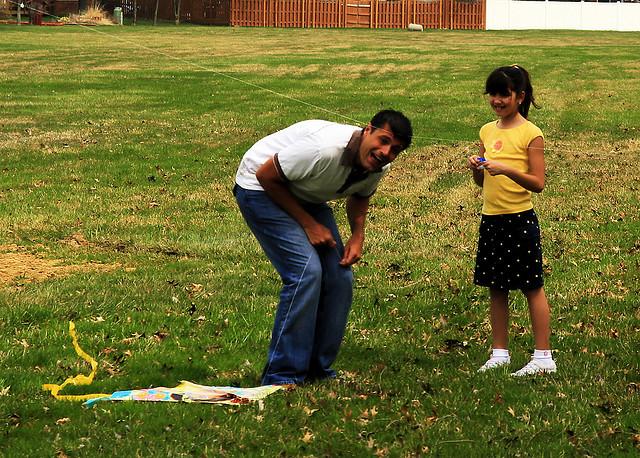What are they trying to fly?
Answer briefly. Kite. Are they both wearing shoes?
Be succinct. Yes. Is he bending?
Keep it brief. Yes. 